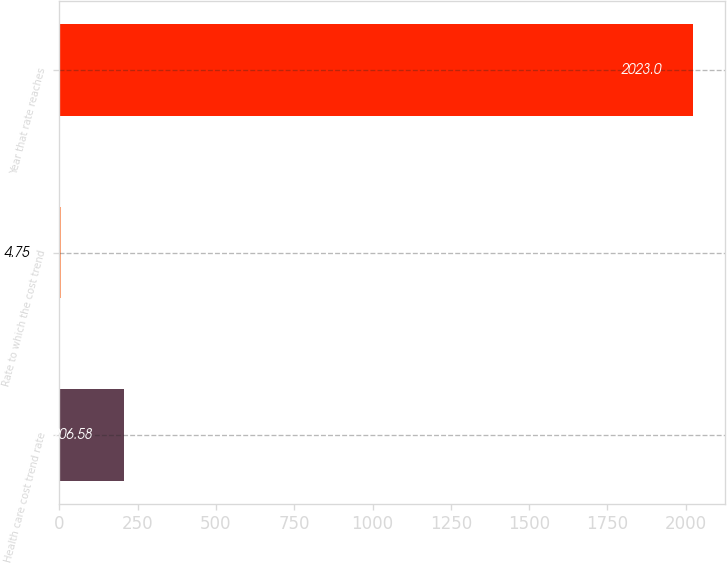Convert chart to OTSL. <chart><loc_0><loc_0><loc_500><loc_500><bar_chart><fcel>Health care cost trend rate<fcel>Rate to which the cost trend<fcel>Year that rate reaches<nl><fcel>206.58<fcel>4.75<fcel>2023<nl></chart> 